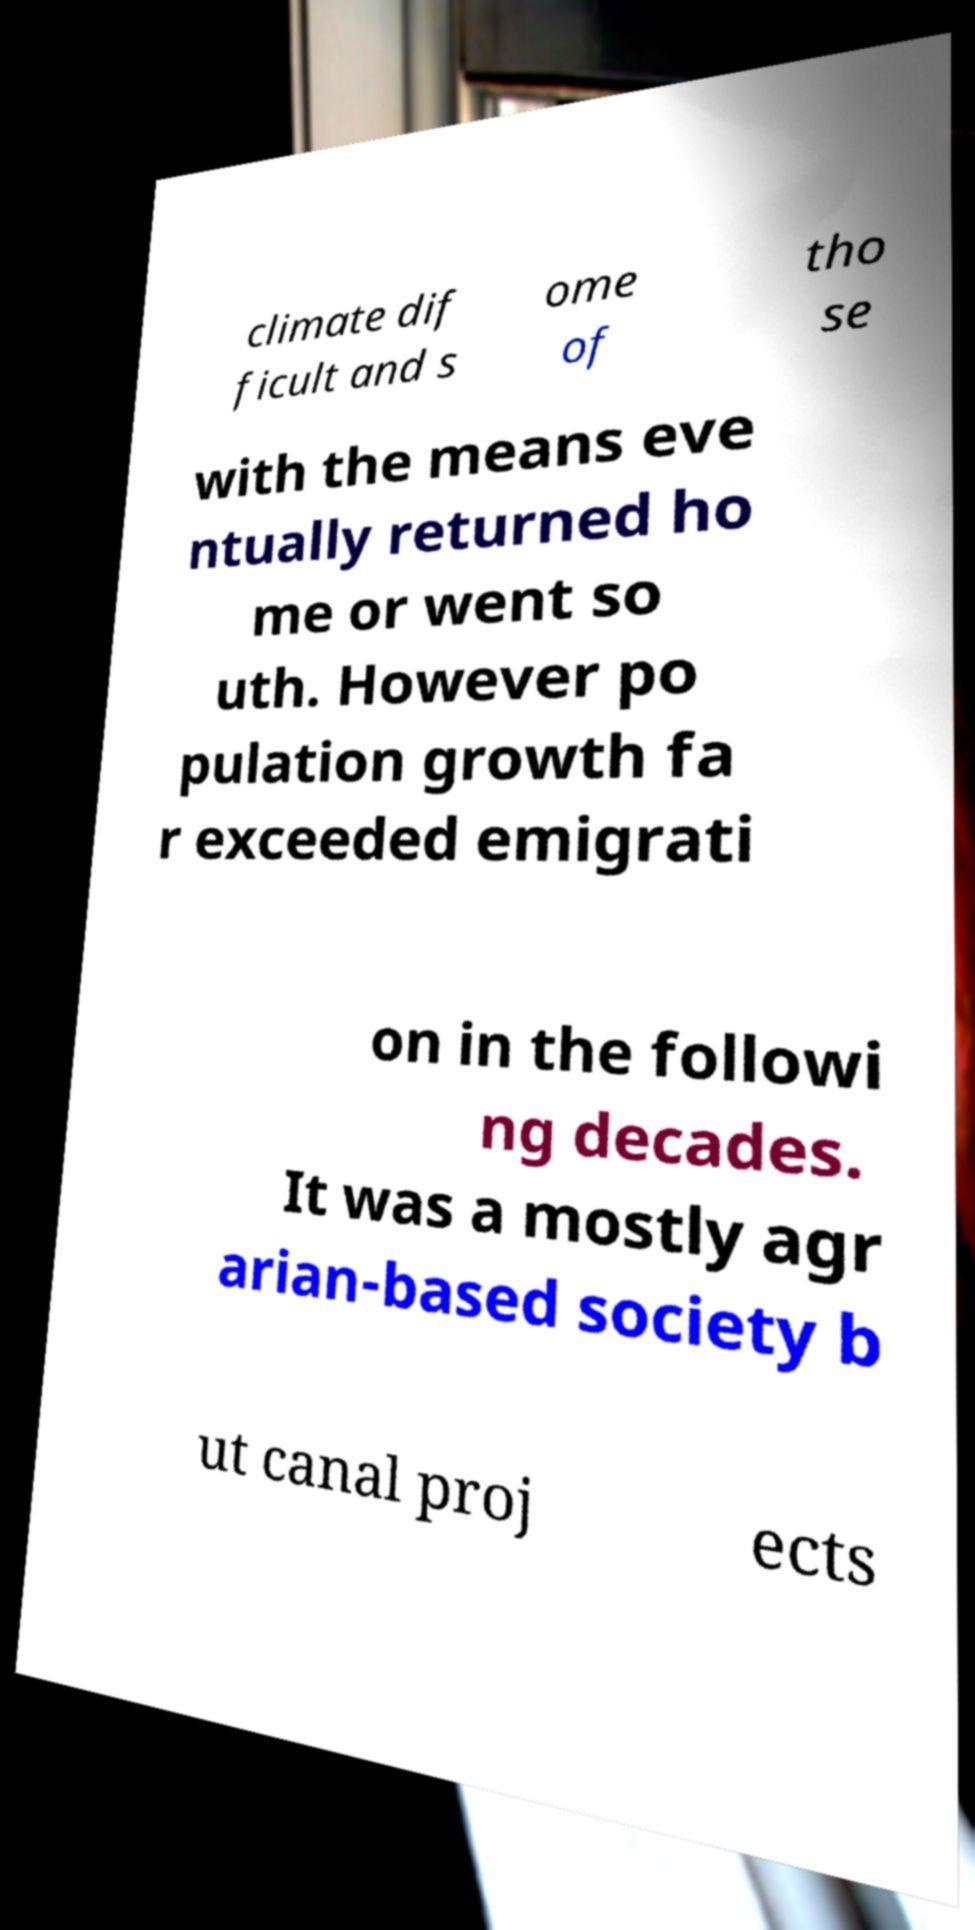For documentation purposes, I need the text within this image transcribed. Could you provide that? climate dif ficult and s ome of tho se with the means eve ntually returned ho me or went so uth. However po pulation growth fa r exceeded emigrati on in the followi ng decades. It was a mostly agr arian-based society b ut canal proj ects 